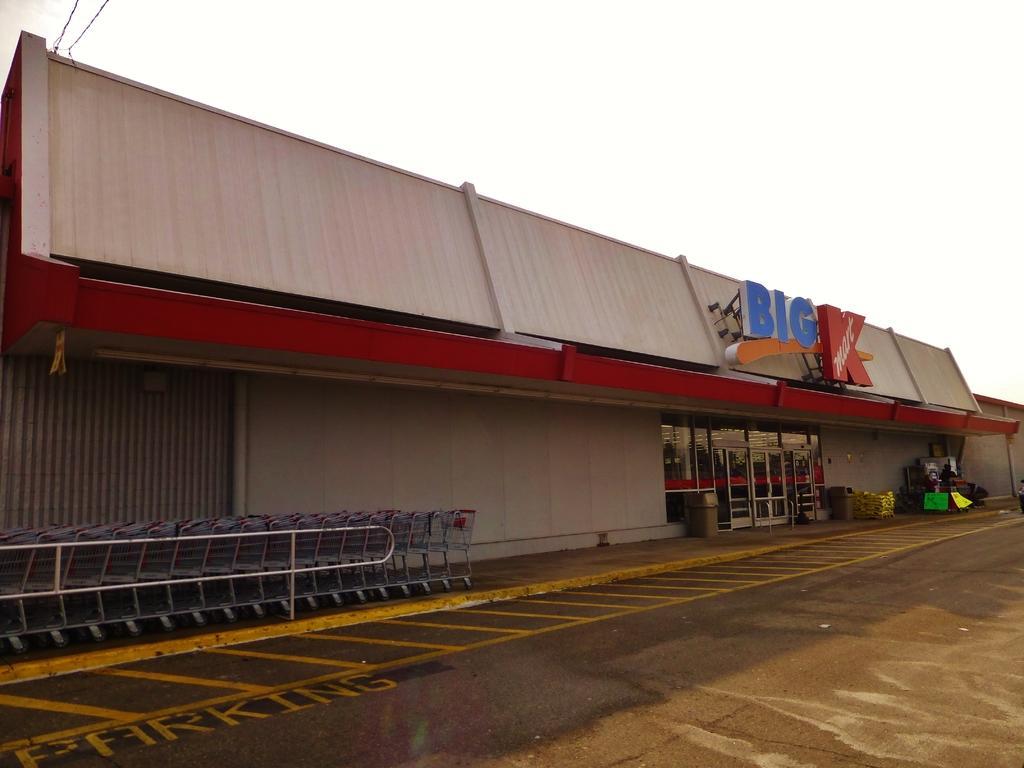How would you summarize this image in a sentence or two? In this image, we can see a store with glass doors and walls. Here we can see carts, rods, dustbins and few objects. At the bottom, there is a road. Background we can see the sky. 